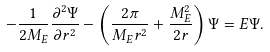<formula> <loc_0><loc_0><loc_500><loc_500>- \frac { 1 } { 2 M _ { E } } \frac { \partial ^ { 2 } \Psi } { \partial r ^ { 2 } } - \left ( \frac { 2 \pi } { M _ { E } r ^ { 2 } } + \frac { M _ { E } ^ { 2 } } { 2 r } \right ) \Psi = E \Psi .</formula> 